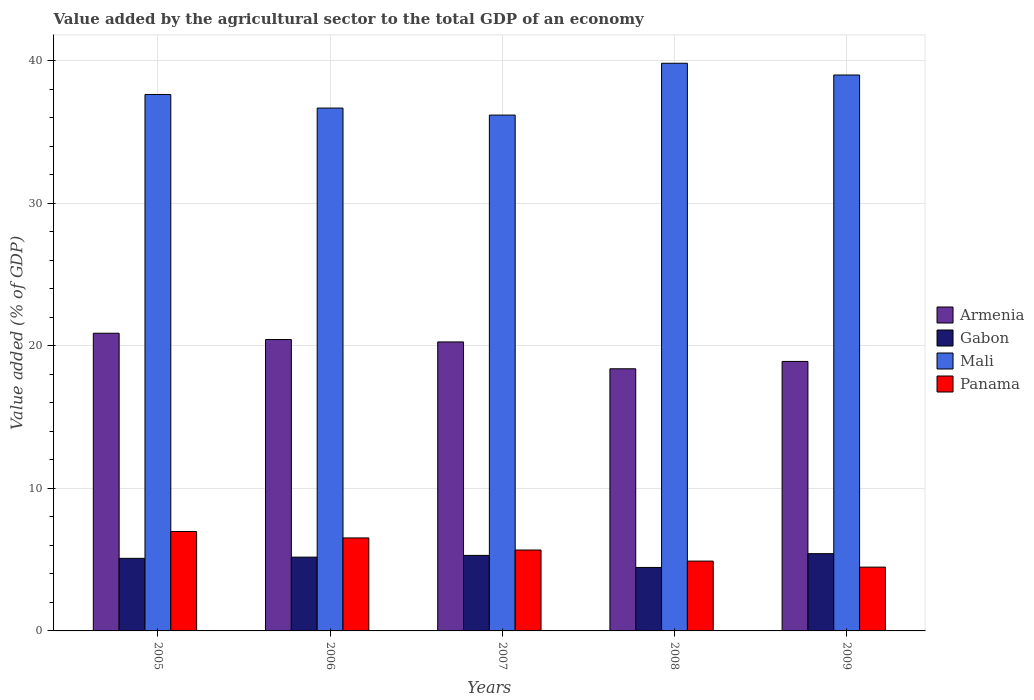How many groups of bars are there?
Give a very brief answer. 5. How many bars are there on the 1st tick from the right?
Your answer should be very brief. 4. What is the value added by the agricultural sector to the total GDP in Gabon in 2009?
Provide a short and direct response. 5.42. Across all years, what is the maximum value added by the agricultural sector to the total GDP in Panama?
Your response must be concise. 6.98. Across all years, what is the minimum value added by the agricultural sector to the total GDP in Panama?
Give a very brief answer. 4.48. What is the total value added by the agricultural sector to the total GDP in Gabon in the graph?
Keep it short and to the point. 25.45. What is the difference between the value added by the agricultural sector to the total GDP in Gabon in 2005 and that in 2006?
Offer a very short reply. -0.08. What is the difference between the value added by the agricultural sector to the total GDP in Gabon in 2009 and the value added by the agricultural sector to the total GDP in Panama in 2006?
Offer a terse response. -1.1. What is the average value added by the agricultural sector to the total GDP in Gabon per year?
Provide a short and direct response. 5.09. In the year 2007, what is the difference between the value added by the agricultural sector to the total GDP in Gabon and value added by the agricultural sector to the total GDP in Mali?
Ensure brevity in your answer.  -30.9. What is the ratio of the value added by the agricultural sector to the total GDP in Mali in 2005 to that in 2007?
Keep it short and to the point. 1.04. Is the difference between the value added by the agricultural sector to the total GDP in Gabon in 2006 and 2008 greater than the difference between the value added by the agricultural sector to the total GDP in Mali in 2006 and 2008?
Offer a terse response. Yes. What is the difference between the highest and the second highest value added by the agricultural sector to the total GDP in Armenia?
Offer a very short reply. 0.44. What is the difference between the highest and the lowest value added by the agricultural sector to the total GDP in Panama?
Your answer should be compact. 2.5. What does the 4th bar from the left in 2006 represents?
Offer a terse response. Panama. What does the 1st bar from the right in 2006 represents?
Provide a short and direct response. Panama. Is it the case that in every year, the sum of the value added by the agricultural sector to the total GDP in Gabon and value added by the agricultural sector to the total GDP in Mali is greater than the value added by the agricultural sector to the total GDP in Armenia?
Make the answer very short. Yes. How many bars are there?
Make the answer very short. 20. Are all the bars in the graph horizontal?
Ensure brevity in your answer.  No. Does the graph contain any zero values?
Your answer should be compact. No. Where does the legend appear in the graph?
Make the answer very short. Center right. How many legend labels are there?
Offer a very short reply. 4. How are the legend labels stacked?
Offer a very short reply. Vertical. What is the title of the graph?
Offer a terse response. Value added by the agricultural sector to the total GDP of an economy. What is the label or title of the Y-axis?
Ensure brevity in your answer.  Value added (% of GDP). What is the Value added (% of GDP) of Armenia in 2005?
Keep it short and to the point. 20.89. What is the Value added (% of GDP) of Gabon in 2005?
Your response must be concise. 5.09. What is the Value added (% of GDP) of Mali in 2005?
Offer a terse response. 37.65. What is the Value added (% of GDP) in Panama in 2005?
Your answer should be compact. 6.98. What is the Value added (% of GDP) of Armenia in 2006?
Your answer should be compact. 20.45. What is the Value added (% of GDP) of Gabon in 2006?
Your response must be concise. 5.18. What is the Value added (% of GDP) in Mali in 2006?
Your answer should be very brief. 36.7. What is the Value added (% of GDP) of Panama in 2006?
Offer a terse response. 6.53. What is the Value added (% of GDP) in Armenia in 2007?
Provide a succinct answer. 20.28. What is the Value added (% of GDP) of Gabon in 2007?
Make the answer very short. 5.3. What is the Value added (% of GDP) of Mali in 2007?
Make the answer very short. 36.2. What is the Value added (% of GDP) in Panama in 2007?
Your response must be concise. 5.68. What is the Value added (% of GDP) in Armenia in 2008?
Give a very brief answer. 18.4. What is the Value added (% of GDP) in Gabon in 2008?
Provide a short and direct response. 4.45. What is the Value added (% of GDP) in Mali in 2008?
Your answer should be compact. 39.84. What is the Value added (% of GDP) of Panama in 2008?
Your response must be concise. 4.9. What is the Value added (% of GDP) in Armenia in 2009?
Offer a terse response. 18.91. What is the Value added (% of GDP) in Gabon in 2009?
Your answer should be very brief. 5.42. What is the Value added (% of GDP) in Mali in 2009?
Give a very brief answer. 39.02. What is the Value added (% of GDP) of Panama in 2009?
Keep it short and to the point. 4.48. Across all years, what is the maximum Value added (% of GDP) in Armenia?
Your answer should be very brief. 20.89. Across all years, what is the maximum Value added (% of GDP) of Gabon?
Your response must be concise. 5.42. Across all years, what is the maximum Value added (% of GDP) of Mali?
Your response must be concise. 39.84. Across all years, what is the maximum Value added (% of GDP) of Panama?
Offer a very short reply. 6.98. Across all years, what is the minimum Value added (% of GDP) of Armenia?
Provide a succinct answer. 18.4. Across all years, what is the minimum Value added (% of GDP) of Gabon?
Offer a terse response. 4.45. Across all years, what is the minimum Value added (% of GDP) in Mali?
Your response must be concise. 36.2. Across all years, what is the minimum Value added (% of GDP) in Panama?
Give a very brief answer. 4.48. What is the total Value added (% of GDP) in Armenia in the graph?
Keep it short and to the point. 98.94. What is the total Value added (% of GDP) of Gabon in the graph?
Make the answer very short. 25.45. What is the total Value added (% of GDP) of Mali in the graph?
Your answer should be compact. 189.4. What is the total Value added (% of GDP) of Panama in the graph?
Your response must be concise. 28.56. What is the difference between the Value added (% of GDP) in Armenia in 2005 and that in 2006?
Provide a short and direct response. 0.44. What is the difference between the Value added (% of GDP) in Gabon in 2005 and that in 2006?
Your answer should be compact. -0.08. What is the difference between the Value added (% of GDP) of Mali in 2005 and that in 2006?
Provide a short and direct response. 0.95. What is the difference between the Value added (% of GDP) of Panama in 2005 and that in 2006?
Give a very brief answer. 0.45. What is the difference between the Value added (% of GDP) in Armenia in 2005 and that in 2007?
Ensure brevity in your answer.  0.61. What is the difference between the Value added (% of GDP) of Gabon in 2005 and that in 2007?
Offer a terse response. -0.21. What is the difference between the Value added (% of GDP) in Mali in 2005 and that in 2007?
Your answer should be compact. 1.45. What is the difference between the Value added (% of GDP) of Panama in 2005 and that in 2007?
Your answer should be compact. 1.3. What is the difference between the Value added (% of GDP) in Armenia in 2005 and that in 2008?
Offer a terse response. 2.49. What is the difference between the Value added (% of GDP) in Gabon in 2005 and that in 2008?
Provide a succinct answer. 0.64. What is the difference between the Value added (% of GDP) of Mali in 2005 and that in 2008?
Offer a very short reply. -2.19. What is the difference between the Value added (% of GDP) of Panama in 2005 and that in 2008?
Provide a succinct answer. 2.08. What is the difference between the Value added (% of GDP) in Armenia in 2005 and that in 2009?
Offer a very short reply. 1.98. What is the difference between the Value added (% of GDP) in Gabon in 2005 and that in 2009?
Provide a short and direct response. -0.33. What is the difference between the Value added (% of GDP) in Mali in 2005 and that in 2009?
Keep it short and to the point. -1.37. What is the difference between the Value added (% of GDP) of Panama in 2005 and that in 2009?
Provide a succinct answer. 2.5. What is the difference between the Value added (% of GDP) of Armenia in 2006 and that in 2007?
Give a very brief answer. 0.17. What is the difference between the Value added (% of GDP) of Gabon in 2006 and that in 2007?
Make the answer very short. -0.12. What is the difference between the Value added (% of GDP) of Mali in 2006 and that in 2007?
Your response must be concise. 0.49. What is the difference between the Value added (% of GDP) in Panama in 2006 and that in 2007?
Provide a succinct answer. 0.85. What is the difference between the Value added (% of GDP) of Armenia in 2006 and that in 2008?
Offer a terse response. 2.05. What is the difference between the Value added (% of GDP) of Gabon in 2006 and that in 2008?
Offer a terse response. 0.72. What is the difference between the Value added (% of GDP) in Mali in 2006 and that in 2008?
Provide a succinct answer. -3.14. What is the difference between the Value added (% of GDP) in Panama in 2006 and that in 2008?
Keep it short and to the point. 1.63. What is the difference between the Value added (% of GDP) of Armenia in 2006 and that in 2009?
Provide a short and direct response. 1.54. What is the difference between the Value added (% of GDP) in Gabon in 2006 and that in 2009?
Your response must be concise. -0.24. What is the difference between the Value added (% of GDP) in Mali in 2006 and that in 2009?
Your answer should be compact. -2.32. What is the difference between the Value added (% of GDP) of Panama in 2006 and that in 2009?
Ensure brevity in your answer.  2.05. What is the difference between the Value added (% of GDP) of Armenia in 2007 and that in 2008?
Your response must be concise. 1.88. What is the difference between the Value added (% of GDP) of Gabon in 2007 and that in 2008?
Your answer should be compact. 0.85. What is the difference between the Value added (% of GDP) in Mali in 2007 and that in 2008?
Offer a very short reply. -3.64. What is the difference between the Value added (% of GDP) of Panama in 2007 and that in 2008?
Offer a very short reply. 0.78. What is the difference between the Value added (% of GDP) of Armenia in 2007 and that in 2009?
Keep it short and to the point. 1.37. What is the difference between the Value added (% of GDP) of Gabon in 2007 and that in 2009?
Your response must be concise. -0.12. What is the difference between the Value added (% of GDP) of Mali in 2007 and that in 2009?
Ensure brevity in your answer.  -2.81. What is the difference between the Value added (% of GDP) of Panama in 2007 and that in 2009?
Provide a short and direct response. 1.2. What is the difference between the Value added (% of GDP) in Armenia in 2008 and that in 2009?
Offer a very short reply. -0.52. What is the difference between the Value added (% of GDP) in Gabon in 2008 and that in 2009?
Your response must be concise. -0.97. What is the difference between the Value added (% of GDP) of Mali in 2008 and that in 2009?
Keep it short and to the point. 0.82. What is the difference between the Value added (% of GDP) in Panama in 2008 and that in 2009?
Make the answer very short. 0.42. What is the difference between the Value added (% of GDP) in Armenia in 2005 and the Value added (% of GDP) in Gabon in 2006?
Provide a short and direct response. 15.71. What is the difference between the Value added (% of GDP) of Armenia in 2005 and the Value added (% of GDP) of Mali in 2006?
Ensure brevity in your answer.  -15.8. What is the difference between the Value added (% of GDP) of Armenia in 2005 and the Value added (% of GDP) of Panama in 2006?
Ensure brevity in your answer.  14.37. What is the difference between the Value added (% of GDP) in Gabon in 2005 and the Value added (% of GDP) in Mali in 2006?
Your answer should be compact. -31.6. What is the difference between the Value added (% of GDP) in Gabon in 2005 and the Value added (% of GDP) in Panama in 2006?
Your response must be concise. -1.43. What is the difference between the Value added (% of GDP) of Mali in 2005 and the Value added (% of GDP) of Panama in 2006?
Your answer should be very brief. 31.12. What is the difference between the Value added (% of GDP) in Armenia in 2005 and the Value added (% of GDP) in Gabon in 2007?
Give a very brief answer. 15.59. What is the difference between the Value added (% of GDP) in Armenia in 2005 and the Value added (% of GDP) in Mali in 2007?
Make the answer very short. -15.31. What is the difference between the Value added (% of GDP) in Armenia in 2005 and the Value added (% of GDP) in Panama in 2007?
Your response must be concise. 15.21. What is the difference between the Value added (% of GDP) of Gabon in 2005 and the Value added (% of GDP) of Mali in 2007?
Your response must be concise. -31.11. What is the difference between the Value added (% of GDP) of Gabon in 2005 and the Value added (% of GDP) of Panama in 2007?
Ensure brevity in your answer.  -0.58. What is the difference between the Value added (% of GDP) of Mali in 2005 and the Value added (% of GDP) of Panama in 2007?
Make the answer very short. 31.97. What is the difference between the Value added (% of GDP) of Armenia in 2005 and the Value added (% of GDP) of Gabon in 2008?
Make the answer very short. 16.44. What is the difference between the Value added (% of GDP) of Armenia in 2005 and the Value added (% of GDP) of Mali in 2008?
Give a very brief answer. -18.95. What is the difference between the Value added (% of GDP) of Armenia in 2005 and the Value added (% of GDP) of Panama in 2008?
Provide a succinct answer. 15.99. What is the difference between the Value added (% of GDP) in Gabon in 2005 and the Value added (% of GDP) in Mali in 2008?
Make the answer very short. -34.75. What is the difference between the Value added (% of GDP) in Gabon in 2005 and the Value added (% of GDP) in Panama in 2008?
Offer a terse response. 0.19. What is the difference between the Value added (% of GDP) in Mali in 2005 and the Value added (% of GDP) in Panama in 2008?
Your answer should be very brief. 32.75. What is the difference between the Value added (% of GDP) of Armenia in 2005 and the Value added (% of GDP) of Gabon in 2009?
Your answer should be very brief. 15.47. What is the difference between the Value added (% of GDP) in Armenia in 2005 and the Value added (% of GDP) in Mali in 2009?
Keep it short and to the point. -18.12. What is the difference between the Value added (% of GDP) of Armenia in 2005 and the Value added (% of GDP) of Panama in 2009?
Make the answer very short. 16.42. What is the difference between the Value added (% of GDP) in Gabon in 2005 and the Value added (% of GDP) in Mali in 2009?
Provide a short and direct response. -33.92. What is the difference between the Value added (% of GDP) in Gabon in 2005 and the Value added (% of GDP) in Panama in 2009?
Your response must be concise. 0.62. What is the difference between the Value added (% of GDP) in Mali in 2005 and the Value added (% of GDP) in Panama in 2009?
Provide a short and direct response. 33.17. What is the difference between the Value added (% of GDP) of Armenia in 2006 and the Value added (% of GDP) of Gabon in 2007?
Provide a succinct answer. 15.15. What is the difference between the Value added (% of GDP) of Armenia in 2006 and the Value added (% of GDP) of Mali in 2007?
Keep it short and to the point. -15.75. What is the difference between the Value added (% of GDP) of Armenia in 2006 and the Value added (% of GDP) of Panama in 2007?
Give a very brief answer. 14.77. What is the difference between the Value added (% of GDP) in Gabon in 2006 and the Value added (% of GDP) in Mali in 2007?
Provide a short and direct response. -31.02. What is the difference between the Value added (% of GDP) in Gabon in 2006 and the Value added (% of GDP) in Panama in 2007?
Provide a short and direct response. -0.5. What is the difference between the Value added (% of GDP) of Mali in 2006 and the Value added (% of GDP) of Panama in 2007?
Give a very brief answer. 31.02. What is the difference between the Value added (% of GDP) in Armenia in 2006 and the Value added (% of GDP) in Gabon in 2008?
Give a very brief answer. 16. What is the difference between the Value added (% of GDP) of Armenia in 2006 and the Value added (% of GDP) of Mali in 2008?
Offer a terse response. -19.39. What is the difference between the Value added (% of GDP) in Armenia in 2006 and the Value added (% of GDP) in Panama in 2008?
Keep it short and to the point. 15.55. What is the difference between the Value added (% of GDP) in Gabon in 2006 and the Value added (% of GDP) in Mali in 2008?
Provide a short and direct response. -34.66. What is the difference between the Value added (% of GDP) of Gabon in 2006 and the Value added (% of GDP) of Panama in 2008?
Provide a succinct answer. 0.28. What is the difference between the Value added (% of GDP) of Mali in 2006 and the Value added (% of GDP) of Panama in 2008?
Ensure brevity in your answer.  31.8. What is the difference between the Value added (% of GDP) of Armenia in 2006 and the Value added (% of GDP) of Gabon in 2009?
Give a very brief answer. 15.03. What is the difference between the Value added (% of GDP) of Armenia in 2006 and the Value added (% of GDP) of Mali in 2009?
Provide a short and direct response. -18.57. What is the difference between the Value added (% of GDP) in Armenia in 2006 and the Value added (% of GDP) in Panama in 2009?
Your answer should be very brief. 15.97. What is the difference between the Value added (% of GDP) in Gabon in 2006 and the Value added (% of GDP) in Mali in 2009?
Give a very brief answer. -33.84. What is the difference between the Value added (% of GDP) in Gabon in 2006 and the Value added (% of GDP) in Panama in 2009?
Your answer should be compact. 0.7. What is the difference between the Value added (% of GDP) in Mali in 2006 and the Value added (% of GDP) in Panama in 2009?
Offer a terse response. 32.22. What is the difference between the Value added (% of GDP) in Armenia in 2007 and the Value added (% of GDP) in Gabon in 2008?
Make the answer very short. 15.83. What is the difference between the Value added (% of GDP) of Armenia in 2007 and the Value added (% of GDP) of Mali in 2008?
Make the answer very short. -19.56. What is the difference between the Value added (% of GDP) of Armenia in 2007 and the Value added (% of GDP) of Panama in 2008?
Your answer should be compact. 15.38. What is the difference between the Value added (% of GDP) of Gabon in 2007 and the Value added (% of GDP) of Mali in 2008?
Offer a terse response. -34.54. What is the difference between the Value added (% of GDP) of Gabon in 2007 and the Value added (% of GDP) of Panama in 2008?
Provide a succinct answer. 0.4. What is the difference between the Value added (% of GDP) of Mali in 2007 and the Value added (% of GDP) of Panama in 2008?
Keep it short and to the point. 31.3. What is the difference between the Value added (% of GDP) in Armenia in 2007 and the Value added (% of GDP) in Gabon in 2009?
Keep it short and to the point. 14.86. What is the difference between the Value added (% of GDP) of Armenia in 2007 and the Value added (% of GDP) of Mali in 2009?
Your answer should be compact. -18.73. What is the difference between the Value added (% of GDP) of Armenia in 2007 and the Value added (% of GDP) of Panama in 2009?
Provide a short and direct response. 15.8. What is the difference between the Value added (% of GDP) in Gabon in 2007 and the Value added (% of GDP) in Mali in 2009?
Ensure brevity in your answer.  -33.72. What is the difference between the Value added (% of GDP) in Gabon in 2007 and the Value added (% of GDP) in Panama in 2009?
Provide a succinct answer. 0.82. What is the difference between the Value added (% of GDP) in Mali in 2007 and the Value added (% of GDP) in Panama in 2009?
Give a very brief answer. 31.73. What is the difference between the Value added (% of GDP) of Armenia in 2008 and the Value added (% of GDP) of Gabon in 2009?
Offer a very short reply. 12.98. What is the difference between the Value added (% of GDP) in Armenia in 2008 and the Value added (% of GDP) in Mali in 2009?
Offer a very short reply. -20.62. What is the difference between the Value added (% of GDP) in Armenia in 2008 and the Value added (% of GDP) in Panama in 2009?
Make the answer very short. 13.92. What is the difference between the Value added (% of GDP) of Gabon in 2008 and the Value added (% of GDP) of Mali in 2009?
Provide a succinct answer. -34.56. What is the difference between the Value added (% of GDP) of Gabon in 2008 and the Value added (% of GDP) of Panama in 2009?
Give a very brief answer. -0.02. What is the difference between the Value added (% of GDP) of Mali in 2008 and the Value added (% of GDP) of Panama in 2009?
Offer a very short reply. 35.36. What is the average Value added (% of GDP) in Armenia per year?
Offer a terse response. 19.79. What is the average Value added (% of GDP) of Gabon per year?
Offer a terse response. 5.09. What is the average Value added (% of GDP) of Mali per year?
Offer a terse response. 37.88. What is the average Value added (% of GDP) of Panama per year?
Offer a very short reply. 5.71. In the year 2005, what is the difference between the Value added (% of GDP) in Armenia and Value added (% of GDP) in Gabon?
Offer a terse response. 15.8. In the year 2005, what is the difference between the Value added (% of GDP) in Armenia and Value added (% of GDP) in Mali?
Your answer should be very brief. -16.76. In the year 2005, what is the difference between the Value added (% of GDP) of Armenia and Value added (% of GDP) of Panama?
Ensure brevity in your answer.  13.91. In the year 2005, what is the difference between the Value added (% of GDP) of Gabon and Value added (% of GDP) of Mali?
Your answer should be very brief. -32.55. In the year 2005, what is the difference between the Value added (% of GDP) in Gabon and Value added (% of GDP) in Panama?
Keep it short and to the point. -1.88. In the year 2005, what is the difference between the Value added (% of GDP) in Mali and Value added (% of GDP) in Panama?
Ensure brevity in your answer.  30.67. In the year 2006, what is the difference between the Value added (% of GDP) of Armenia and Value added (% of GDP) of Gabon?
Offer a terse response. 15.27. In the year 2006, what is the difference between the Value added (% of GDP) of Armenia and Value added (% of GDP) of Mali?
Offer a terse response. -16.24. In the year 2006, what is the difference between the Value added (% of GDP) in Armenia and Value added (% of GDP) in Panama?
Provide a short and direct response. 13.92. In the year 2006, what is the difference between the Value added (% of GDP) in Gabon and Value added (% of GDP) in Mali?
Make the answer very short. -31.52. In the year 2006, what is the difference between the Value added (% of GDP) of Gabon and Value added (% of GDP) of Panama?
Offer a very short reply. -1.35. In the year 2006, what is the difference between the Value added (% of GDP) in Mali and Value added (% of GDP) in Panama?
Give a very brief answer. 30.17. In the year 2007, what is the difference between the Value added (% of GDP) in Armenia and Value added (% of GDP) in Gabon?
Keep it short and to the point. 14.98. In the year 2007, what is the difference between the Value added (% of GDP) in Armenia and Value added (% of GDP) in Mali?
Make the answer very short. -15.92. In the year 2007, what is the difference between the Value added (% of GDP) in Armenia and Value added (% of GDP) in Panama?
Ensure brevity in your answer.  14.6. In the year 2007, what is the difference between the Value added (% of GDP) of Gabon and Value added (% of GDP) of Mali?
Provide a succinct answer. -30.9. In the year 2007, what is the difference between the Value added (% of GDP) of Gabon and Value added (% of GDP) of Panama?
Offer a terse response. -0.38. In the year 2007, what is the difference between the Value added (% of GDP) of Mali and Value added (% of GDP) of Panama?
Offer a very short reply. 30.52. In the year 2008, what is the difference between the Value added (% of GDP) of Armenia and Value added (% of GDP) of Gabon?
Provide a short and direct response. 13.94. In the year 2008, what is the difference between the Value added (% of GDP) of Armenia and Value added (% of GDP) of Mali?
Offer a terse response. -21.44. In the year 2008, what is the difference between the Value added (% of GDP) in Armenia and Value added (% of GDP) in Panama?
Offer a very short reply. 13.5. In the year 2008, what is the difference between the Value added (% of GDP) in Gabon and Value added (% of GDP) in Mali?
Ensure brevity in your answer.  -35.39. In the year 2008, what is the difference between the Value added (% of GDP) in Gabon and Value added (% of GDP) in Panama?
Your answer should be compact. -0.45. In the year 2008, what is the difference between the Value added (% of GDP) in Mali and Value added (% of GDP) in Panama?
Offer a very short reply. 34.94. In the year 2009, what is the difference between the Value added (% of GDP) in Armenia and Value added (% of GDP) in Gabon?
Make the answer very short. 13.49. In the year 2009, what is the difference between the Value added (% of GDP) of Armenia and Value added (% of GDP) of Mali?
Offer a terse response. -20.1. In the year 2009, what is the difference between the Value added (% of GDP) of Armenia and Value added (% of GDP) of Panama?
Offer a very short reply. 14.44. In the year 2009, what is the difference between the Value added (% of GDP) in Gabon and Value added (% of GDP) in Mali?
Keep it short and to the point. -33.59. In the year 2009, what is the difference between the Value added (% of GDP) in Gabon and Value added (% of GDP) in Panama?
Your answer should be compact. 0.94. In the year 2009, what is the difference between the Value added (% of GDP) of Mali and Value added (% of GDP) of Panama?
Make the answer very short. 34.54. What is the ratio of the Value added (% of GDP) of Armenia in 2005 to that in 2006?
Offer a very short reply. 1.02. What is the ratio of the Value added (% of GDP) of Gabon in 2005 to that in 2006?
Ensure brevity in your answer.  0.98. What is the ratio of the Value added (% of GDP) in Mali in 2005 to that in 2006?
Keep it short and to the point. 1.03. What is the ratio of the Value added (% of GDP) of Panama in 2005 to that in 2006?
Provide a succinct answer. 1.07. What is the ratio of the Value added (% of GDP) of Armenia in 2005 to that in 2007?
Provide a succinct answer. 1.03. What is the ratio of the Value added (% of GDP) in Gabon in 2005 to that in 2007?
Your response must be concise. 0.96. What is the ratio of the Value added (% of GDP) of Panama in 2005 to that in 2007?
Your response must be concise. 1.23. What is the ratio of the Value added (% of GDP) in Armenia in 2005 to that in 2008?
Offer a very short reply. 1.14. What is the ratio of the Value added (% of GDP) of Gabon in 2005 to that in 2008?
Your response must be concise. 1.14. What is the ratio of the Value added (% of GDP) of Mali in 2005 to that in 2008?
Your answer should be very brief. 0.94. What is the ratio of the Value added (% of GDP) in Panama in 2005 to that in 2008?
Make the answer very short. 1.42. What is the ratio of the Value added (% of GDP) in Armenia in 2005 to that in 2009?
Make the answer very short. 1.1. What is the ratio of the Value added (% of GDP) in Gabon in 2005 to that in 2009?
Offer a very short reply. 0.94. What is the ratio of the Value added (% of GDP) of Mali in 2005 to that in 2009?
Your response must be concise. 0.96. What is the ratio of the Value added (% of GDP) of Panama in 2005 to that in 2009?
Your response must be concise. 1.56. What is the ratio of the Value added (% of GDP) in Armenia in 2006 to that in 2007?
Offer a terse response. 1.01. What is the ratio of the Value added (% of GDP) of Gabon in 2006 to that in 2007?
Give a very brief answer. 0.98. What is the ratio of the Value added (% of GDP) of Mali in 2006 to that in 2007?
Give a very brief answer. 1.01. What is the ratio of the Value added (% of GDP) in Panama in 2006 to that in 2007?
Offer a very short reply. 1.15. What is the ratio of the Value added (% of GDP) in Armenia in 2006 to that in 2008?
Make the answer very short. 1.11. What is the ratio of the Value added (% of GDP) in Gabon in 2006 to that in 2008?
Give a very brief answer. 1.16. What is the ratio of the Value added (% of GDP) in Mali in 2006 to that in 2008?
Make the answer very short. 0.92. What is the ratio of the Value added (% of GDP) in Panama in 2006 to that in 2008?
Offer a terse response. 1.33. What is the ratio of the Value added (% of GDP) of Armenia in 2006 to that in 2009?
Ensure brevity in your answer.  1.08. What is the ratio of the Value added (% of GDP) of Gabon in 2006 to that in 2009?
Offer a very short reply. 0.96. What is the ratio of the Value added (% of GDP) in Mali in 2006 to that in 2009?
Offer a terse response. 0.94. What is the ratio of the Value added (% of GDP) of Panama in 2006 to that in 2009?
Give a very brief answer. 1.46. What is the ratio of the Value added (% of GDP) of Armenia in 2007 to that in 2008?
Provide a short and direct response. 1.1. What is the ratio of the Value added (% of GDP) of Gabon in 2007 to that in 2008?
Give a very brief answer. 1.19. What is the ratio of the Value added (% of GDP) of Mali in 2007 to that in 2008?
Your answer should be very brief. 0.91. What is the ratio of the Value added (% of GDP) of Panama in 2007 to that in 2008?
Provide a short and direct response. 1.16. What is the ratio of the Value added (% of GDP) in Armenia in 2007 to that in 2009?
Your answer should be very brief. 1.07. What is the ratio of the Value added (% of GDP) in Gabon in 2007 to that in 2009?
Ensure brevity in your answer.  0.98. What is the ratio of the Value added (% of GDP) of Mali in 2007 to that in 2009?
Provide a short and direct response. 0.93. What is the ratio of the Value added (% of GDP) in Panama in 2007 to that in 2009?
Your answer should be very brief. 1.27. What is the ratio of the Value added (% of GDP) in Armenia in 2008 to that in 2009?
Provide a short and direct response. 0.97. What is the ratio of the Value added (% of GDP) in Gabon in 2008 to that in 2009?
Provide a short and direct response. 0.82. What is the ratio of the Value added (% of GDP) in Mali in 2008 to that in 2009?
Offer a terse response. 1.02. What is the ratio of the Value added (% of GDP) in Panama in 2008 to that in 2009?
Your answer should be compact. 1.09. What is the difference between the highest and the second highest Value added (% of GDP) in Armenia?
Keep it short and to the point. 0.44. What is the difference between the highest and the second highest Value added (% of GDP) in Gabon?
Keep it short and to the point. 0.12. What is the difference between the highest and the second highest Value added (% of GDP) in Mali?
Your answer should be compact. 0.82. What is the difference between the highest and the second highest Value added (% of GDP) in Panama?
Give a very brief answer. 0.45. What is the difference between the highest and the lowest Value added (% of GDP) of Armenia?
Keep it short and to the point. 2.49. What is the difference between the highest and the lowest Value added (% of GDP) of Gabon?
Make the answer very short. 0.97. What is the difference between the highest and the lowest Value added (% of GDP) of Mali?
Ensure brevity in your answer.  3.64. What is the difference between the highest and the lowest Value added (% of GDP) in Panama?
Provide a succinct answer. 2.5. 